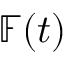<formula> <loc_0><loc_0><loc_500><loc_500>\mathbb { F } ( t )</formula> 